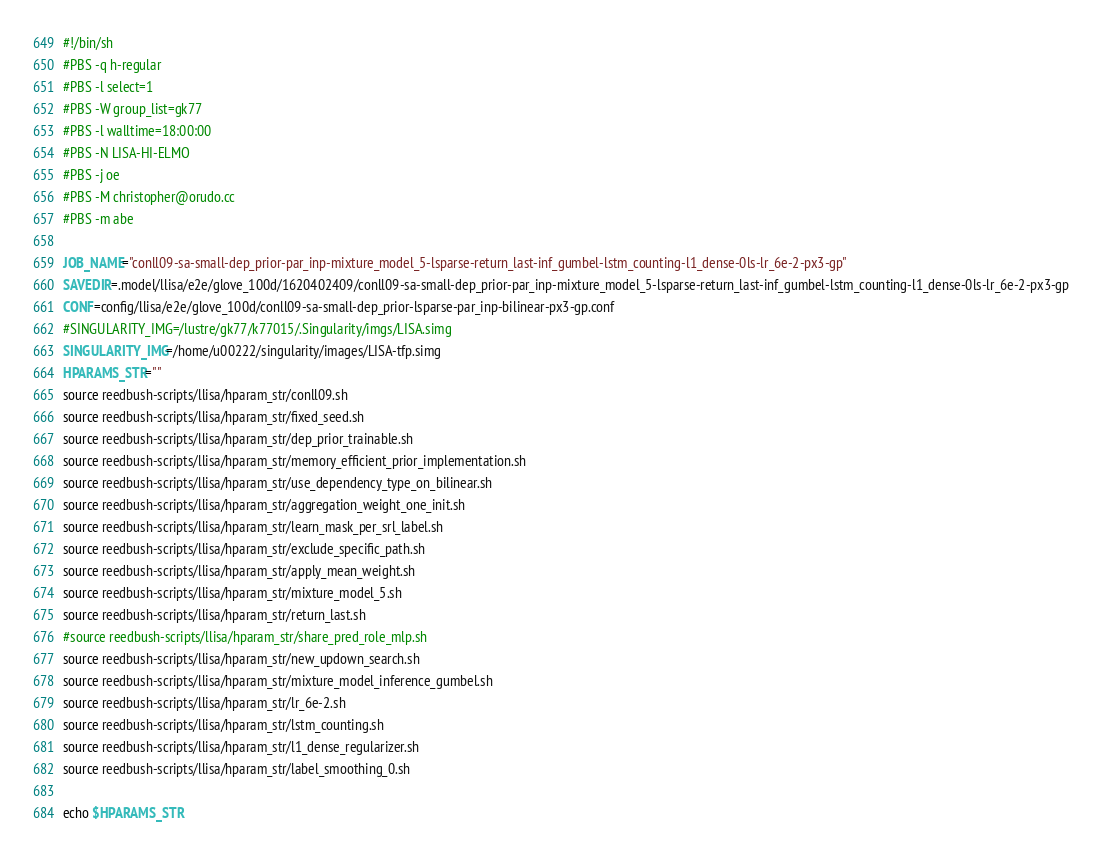<code> <loc_0><loc_0><loc_500><loc_500><_Bash_>#!/bin/sh
#PBS -q h-regular
#PBS -l select=1
#PBS -W group_list=gk77
#PBS -l walltime=18:00:00
#PBS -N LISA-HI-ELMO
#PBS -j oe
#PBS -M christopher@orudo.cc
#PBS -m abe

JOB_NAME="conll09-sa-small-dep_prior-par_inp-mixture_model_5-lsparse-return_last-inf_gumbel-lstm_counting-l1_dense-0ls-lr_6e-2-px3-gp"
SAVEDIR=.model/llisa/e2e/glove_100d/1620402409/conll09-sa-small-dep_prior-par_inp-mixture_model_5-lsparse-return_last-inf_gumbel-lstm_counting-l1_dense-0ls-lr_6e-2-px3-gp
CONF=config/llisa/e2e/glove_100d/conll09-sa-small-dep_prior-lsparse-par_inp-bilinear-px3-gp.conf
#SINGULARITY_IMG=/lustre/gk77/k77015/.Singularity/imgs/LISA.simg
SINGULARITY_IMG=/home/u00222/singularity/images/LISA-tfp.simg
HPARAMS_STR=""
source reedbush-scripts/llisa/hparam_str/conll09.sh
source reedbush-scripts/llisa/hparam_str/fixed_seed.sh
source reedbush-scripts/llisa/hparam_str/dep_prior_trainable.sh
source reedbush-scripts/llisa/hparam_str/memory_efficient_prior_implementation.sh
source reedbush-scripts/llisa/hparam_str/use_dependency_type_on_bilinear.sh
source reedbush-scripts/llisa/hparam_str/aggregation_weight_one_init.sh
source reedbush-scripts/llisa/hparam_str/learn_mask_per_srl_label.sh
source reedbush-scripts/llisa/hparam_str/exclude_specific_path.sh
source reedbush-scripts/llisa/hparam_str/apply_mean_weight.sh
source reedbush-scripts/llisa/hparam_str/mixture_model_5.sh
source reedbush-scripts/llisa/hparam_str/return_last.sh
#source reedbush-scripts/llisa/hparam_str/share_pred_role_mlp.sh
source reedbush-scripts/llisa/hparam_str/new_updown_search.sh
source reedbush-scripts/llisa/hparam_str/mixture_model_inference_gumbel.sh
source reedbush-scripts/llisa/hparam_str/lr_6e-2.sh
source reedbush-scripts/llisa/hparam_str/lstm_counting.sh
source reedbush-scripts/llisa/hparam_str/l1_dense_regularizer.sh
source reedbush-scripts/llisa/hparam_str/label_smoothing_0.sh

echo $HPARAMS_STR</code> 